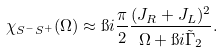Convert formula to latex. <formula><loc_0><loc_0><loc_500><loc_500>\chi _ { S ^ { - } S ^ { + } } ( \Omega ) \approx \i i \frac { \pi } { 2 } \frac { ( J _ { R } + J _ { L } ) ^ { 2 } } { \Omega + \i i \tilde { \Gamma } _ { 2 } } .</formula> 